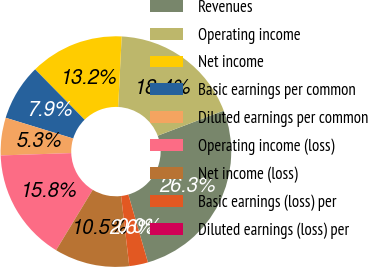Convert chart. <chart><loc_0><loc_0><loc_500><loc_500><pie_chart><fcel>Revenues<fcel>Operating income<fcel>Net income<fcel>Basic earnings per common<fcel>Diluted earnings per common<fcel>Operating income (loss)<fcel>Net income (loss)<fcel>Basic earnings (loss) per<fcel>Diluted earnings (loss) per<nl><fcel>26.31%<fcel>18.42%<fcel>13.16%<fcel>7.9%<fcel>5.27%<fcel>15.79%<fcel>10.53%<fcel>2.63%<fcel>0.0%<nl></chart> 